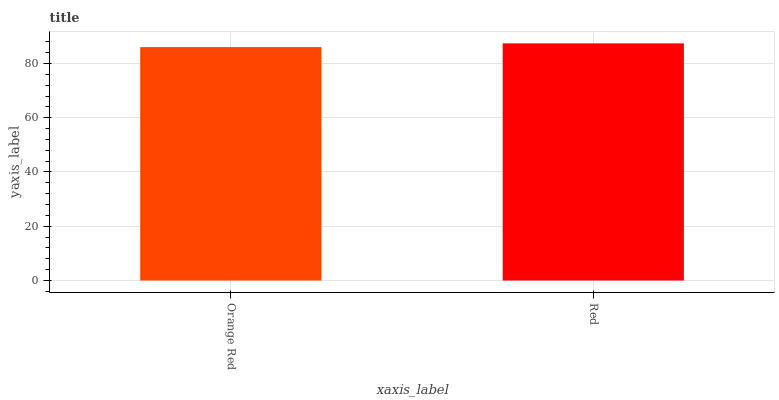Is Orange Red the minimum?
Answer yes or no. Yes. Is Red the maximum?
Answer yes or no. Yes. Is Red the minimum?
Answer yes or no. No. Is Red greater than Orange Red?
Answer yes or no. Yes. Is Orange Red less than Red?
Answer yes or no. Yes. Is Orange Red greater than Red?
Answer yes or no. No. Is Red less than Orange Red?
Answer yes or no. No. Is Red the high median?
Answer yes or no. Yes. Is Orange Red the low median?
Answer yes or no. Yes. Is Orange Red the high median?
Answer yes or no. No. Is Red the low median?
Answer yes or no. No. 